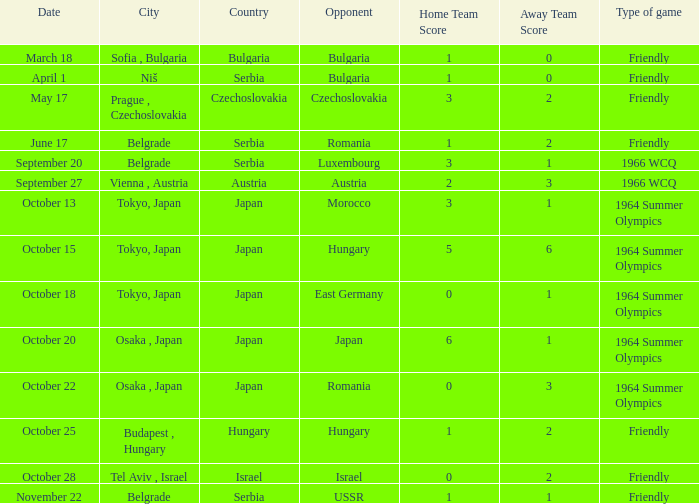What day were the results 3:2? May 17. Write the full table. {'header': ['Date', 'City', 'Country', 'Opponent', 'Home Team Score', 'Away Team Score', 'Type of game'], 'rows': [['March 18', 'Sofia , Bulgaria', 'Bulgaria', 'Bulgaria', '1', '0', 'Friendly'], ['April 1', 'Niš', 'Serbia', 'Bulgaria', '1', '0', 'Friendly'], ['May 17', 'Prague , Czechoslovakia', 'Czechoslovakia', 'Czechoslovakia', '3', '2', 'Friendly'], ['June 17', 'Belgrade', 'Serbia', 'Romania', '1', '2', 'Friendly'], ['September 20', 'Belgrade', 'Serbia', 'Luxembourg', '3', '1', '1966 WCQ'], ['September 27', 'Vienna , Austria', 'Austria', 'Austria', '2', '3', '1966 WCQ'], ['October 13', 'Tokyo, Japan', 'Japan', 'Morocco', '3', '1', '1964 Summer Olympics'], ['October 15', 'Tokyo, Japan', 'Japan', 'Hungary', '5', '6', '1964 Summer Olympics'], ['October 18', 'Tokyo, Japan', 'Japan', 'East Germany', '0', '1', '1964 Summer Olympics'], ['October 20', 'Osaka , Japan', 'Japan', 'Japan', '6', '1', '1964 Summer Olympics'], ['October 22', 'Osaka , Japan', 'Japan', 'Romania', '0', '3', '1964 Summer Olympics'], ['October 25', 'Budapest , Hungary', 'Hungary', 'Hungary', '1', '2', 'Friendly'], ['October 28', 'Tel Aviv , Israel', 'Israel', 'Israel', '0', '2', 'Friendly'], ['November 22', 'Belgrade', 'Serbia', 'USSR', '1', '1', 'Friendly']]} 